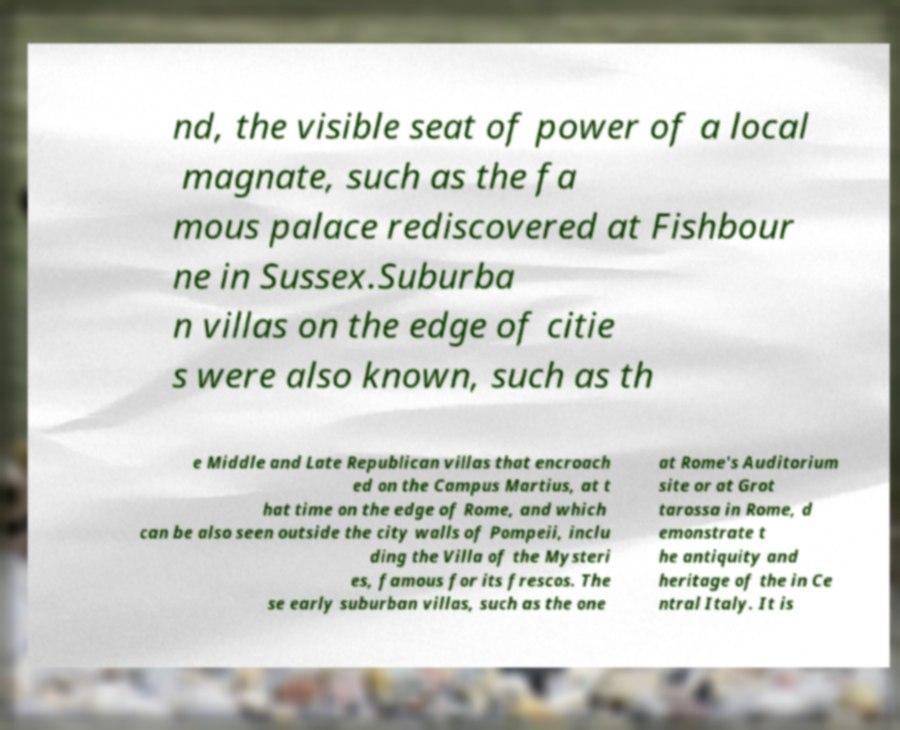Can you read and provide the text displayed in the image?This photo seems to have some interesting text. Can you extract and type it out for me? nd, the visible seat of power of a local magnate, such as the fa mous palace rediscovered at Fishbour ne in Sussex.Suburba n villas on the edge of citie s were also known, such as th e Middle and Late Republican villas that encroach ed on the Campus Martius, at t hat time on the edge of Rome, and which can be also seen outside the city walls of Pompeii, inclu ding the Villa of the Mysteri es, famous for its frescos. The se early suburban villas, such as the one at Rome's Auditorium site or at Grot tarossa in Rome, d emonstrate t he antiquity and heritage of the in Ce ntral Italy. It is 